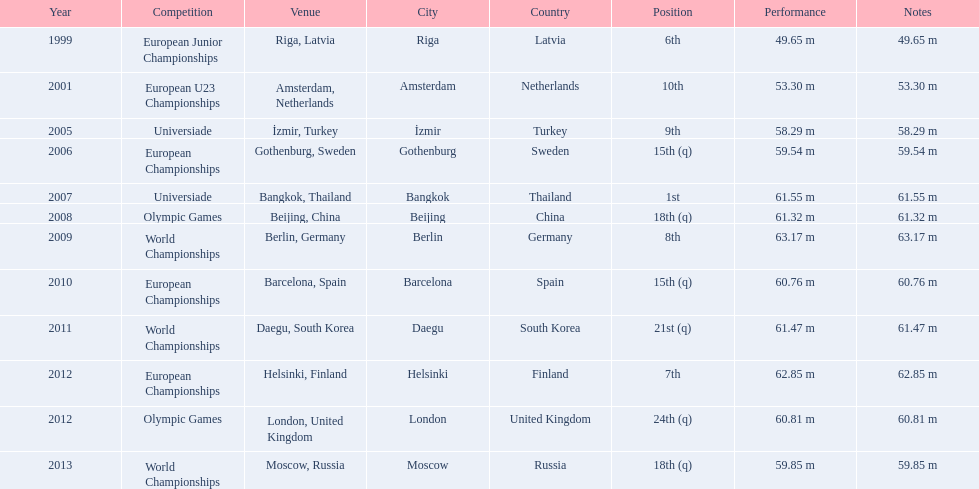What are all the competitions? European Junior Championships, European U23 Championships, Universiade, European Championships, Universiade, Olympic Games, World Championships, European Championships, World Championships, European Championships, Olympic Games, World Championships. What years did they place in the top 10? 1999, 2001, 2005, 2007, 2009, 2012. Besides when they placed first, which position was their highest? 6th. 